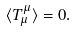Convert formula to latex. <formula><loc_0><loc_0><loc_500><loc_500>\langle T ^ { \mu } _ { \mu } \rangle = 0 .</formula> 